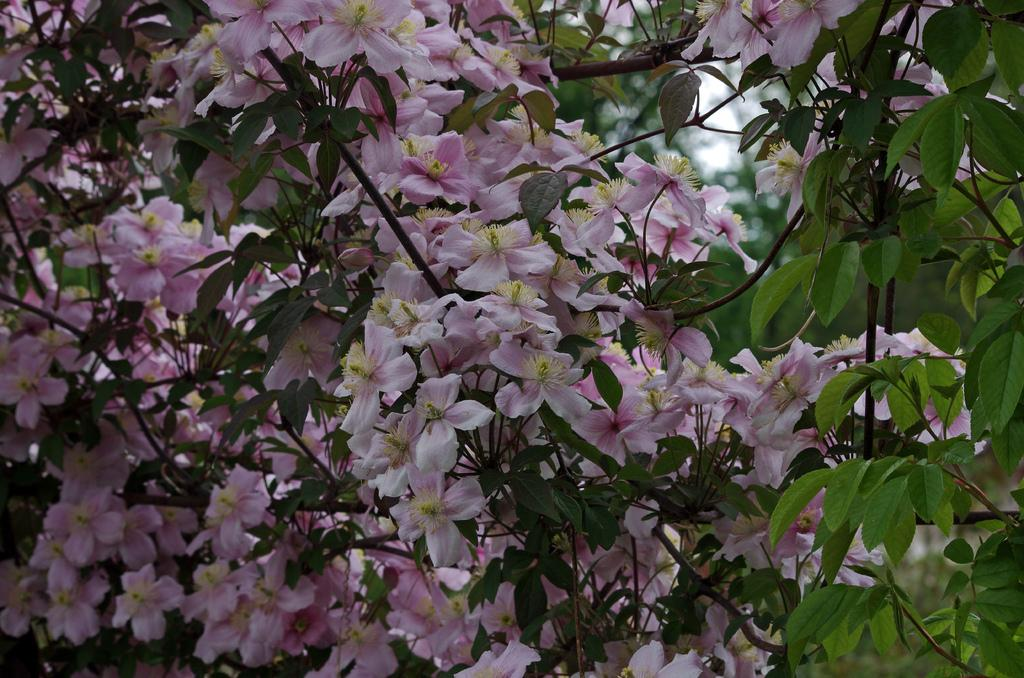What type of plant can be seen in the image? There is a tree in the image. What specific features can be observed on the tree? The tree has flowers, branches, and leaves. What color are the flowers on the tree? The flowers on the tree are light pink in color. How many porters are carrying the boys on the side of the tree in the image? There are no porters or boys present in the image; it features a tree with flowers, branches, and leaves. 